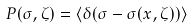<formula> <loc_0><loc_0><loc_500><loc_500>P ( \sigma , \zeta ) = \langle \delta ( \sigma - \sigma ( { x } , \zeta ) ) \rangle</formula> 